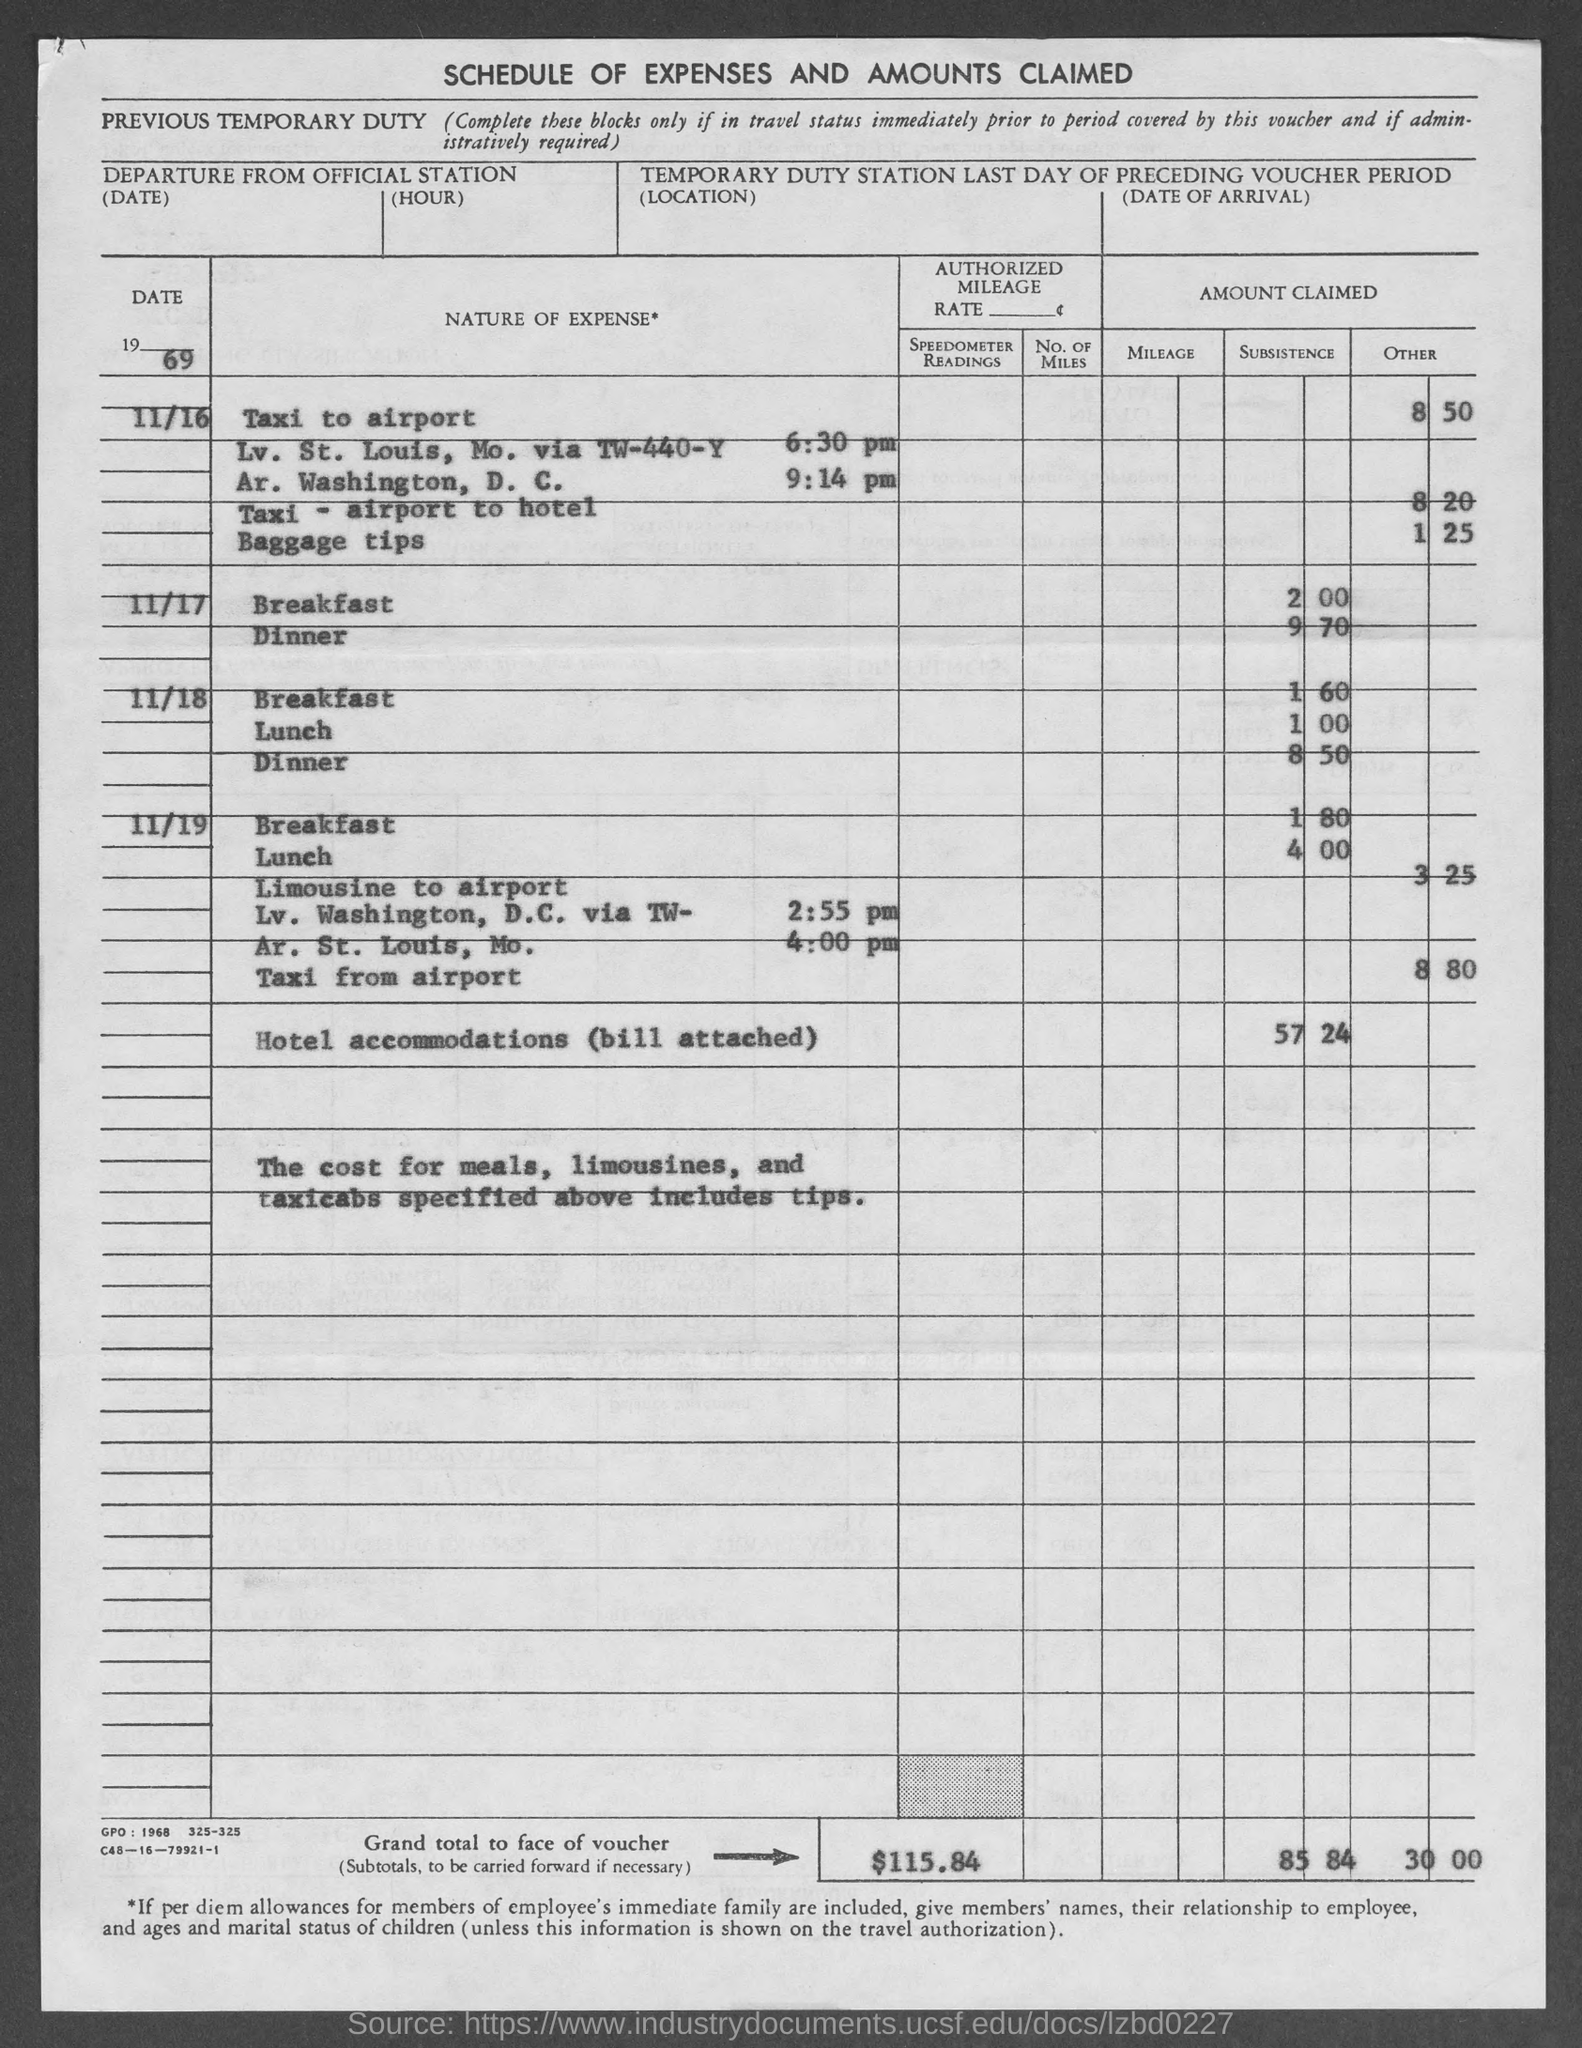What is the grand total amount to face of voucher as mentioned in the given page ?
Offer a very short reply. $115.84. 